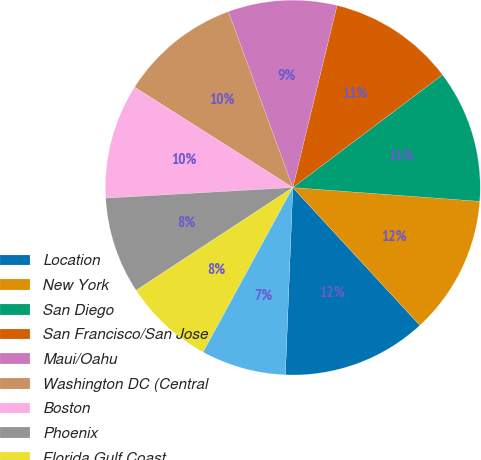Convert chart to OTSL. <chart><loc_0><loc_0><loc_500><loc_500><pie_chart><fcel>Location<fcel>New York<fcel>San Diego<fcel>San Francisco/San Jose<fcel>Maui/Oahu<fcel>Washington DC (Central<fcel>Boston<fcel>Phoenix<fcel>Florida Gulf Coast<fcel>Orlando<nl><fcel>12.49%<fcel>11.97%<fcel>11.45%<fcel>10.93%<fcel>9.38%<fcel>10.41%<fcel>9.9%<fcel>8.34%<fcel>7.82%<fcel>7.31%<nl></chart> 